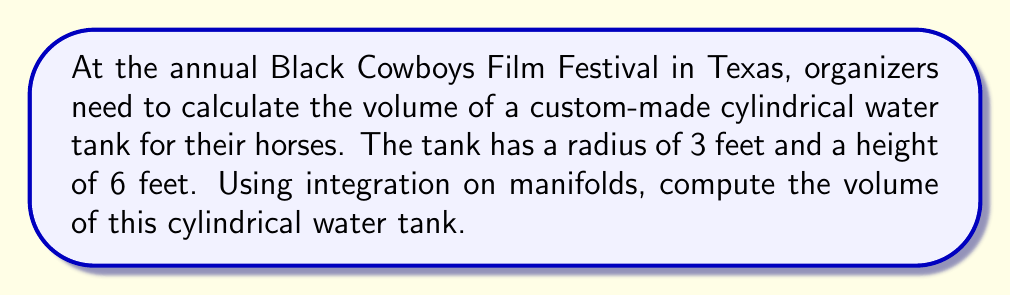Provide a solution to this math problem. To calculate the volume of a cylindrical water tank using integration on manifolds, we'll follow these steps:

1) First, we need to parameterize the cylinder. Let's use cylindrical coordinates $(r, \theta, z)$, where:
   $0 \leq r \leq 3$ (radius)
   $0 \leq \theta \leq 2\pi$ (angle)
   $0 \leq z \leq 6$ (height)

2) The parameterization of the cylinder is:
   $x = r \cos(\theta)$
   $y = r \sin(\theta)$
   $z = z$

3) Now, we need to compute the volume form. In cylindrical coordinates, the volume form is:
   $dV = r \, dr \, d\theta \, dz$

4) The volume is then given by the triple integral:

   $$V = \iiint_M dV = \int_0^6 \int_0^{2\pi} \int_0^3 r \, dr \, d\theta \, dz$$

5) Let's evaluate this integral:
   
   $$V = \int_0^6 \int_0^{2\pi} \int_0^3 r \, dr \, d\theta \, dz$$
   
   $$= \int_0^6 \int_0^{2\pi} \left[\frac{r^2}{2}\right]_0^3 \, d\theta \, dz$$
   
   $$= \int_0^6 \int_0^{2\pi} \frac{9}{2} \, d\theta \, dz$$
   
   $$= \int_0^6 \left[9\pi\right] \, dz$$
   
   $$= 9\pi \left[z\right]_0^6$$
   
   $$= 54\pi$$

6) The volume is in cubic feet, so our final answer is $54\pi$ cubic feet.
Answer: The volume of the cylindrical water tank is $54\pi$ cubic feet. 